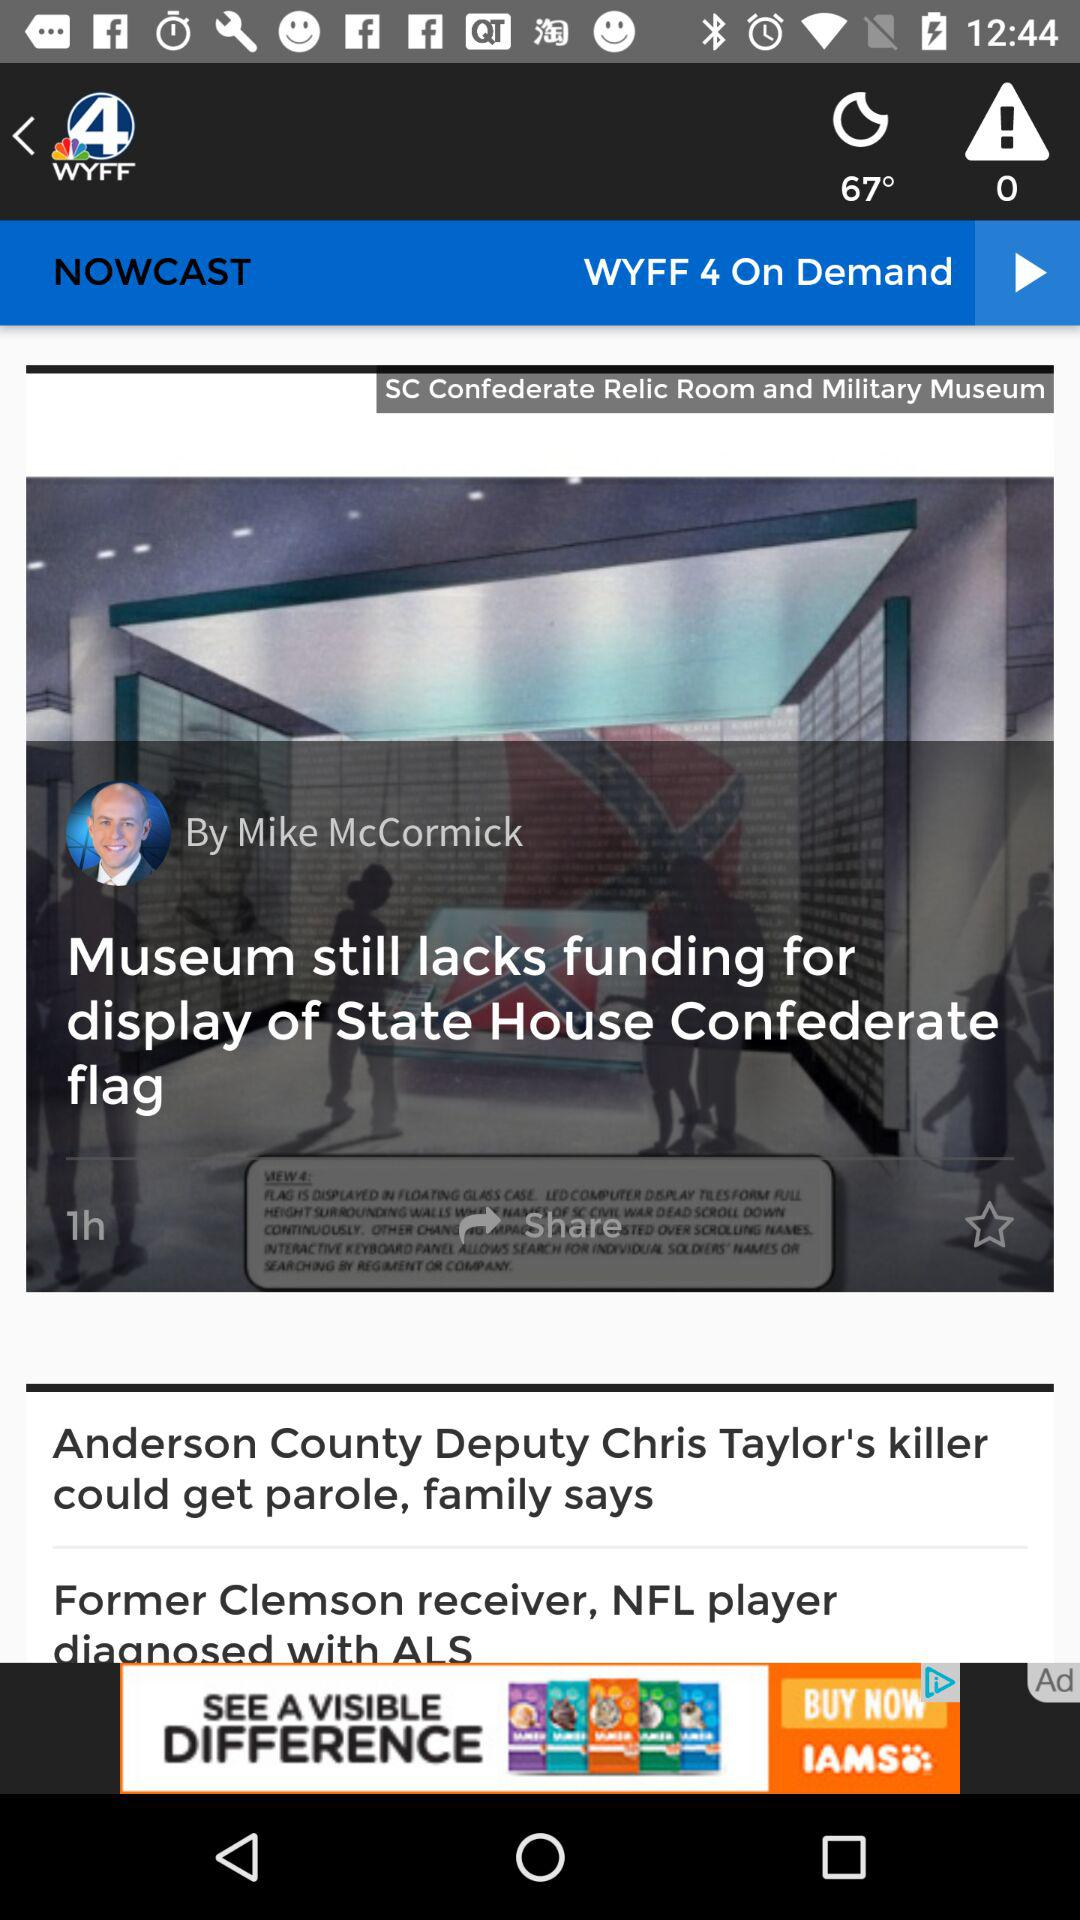Who is the reporter of the news? The reporter is Mike McCormick. 